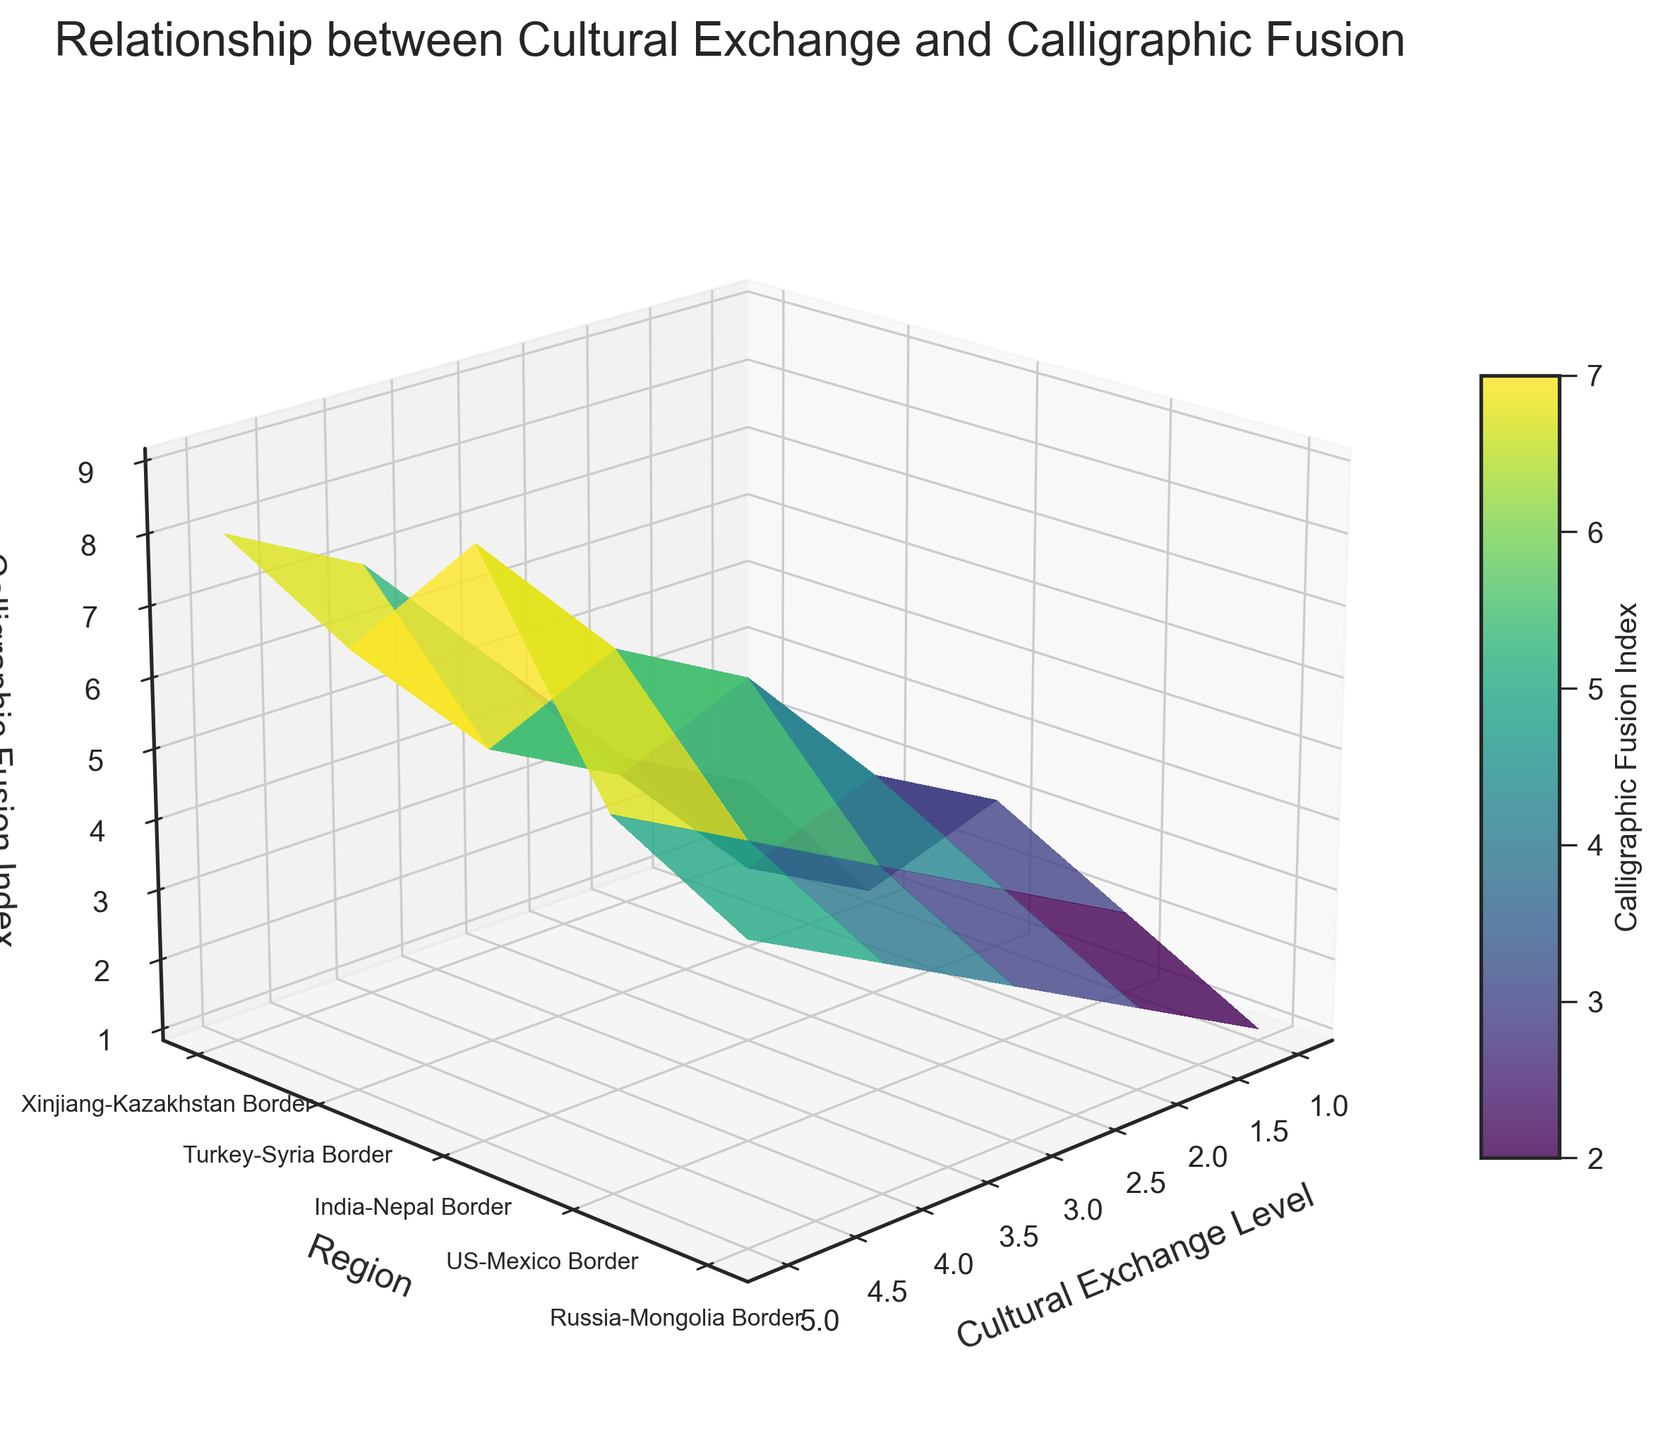What is the title of the plot? The title of the plot is usually located at the top of the figure. In this case, it reads "Relationship between Cultural Exchange and Calligraphic Fusion".
Answer: Relationship between Cultural Exchange and Calligraphic Fusion What do the colors represent in the plot? In a 3D surface plot, the colors usually indicate varying values on the z-axis. Here, the color represents the Calligraphic Fusion Index, as also denoted by the color bar.
Answer: Calligraphic Fusion Index Which region shows the highest Calligraphic Fusion Index? By examining the height of the peaks in the Z dimension, the India-Nepal Border shows the highest peak corresponding to the highest Calligraphic Fusion Index.
Answer: India-Nepal Border How does the Calligraphic Fusion Index change in the Xinjiang-Kazakhstan Border region as the Cultural Exchange Level increases? Observing the plot, the Calligraphic Fusion Index in the Xinjiang-Kazakhstan Border region appears to increase steadily as the Cultural Exchange Level goes from 1 to 5.
Answer: Increases steadily Does any region have a constant Calligraphic Fusion Index regardless of the Cultural Exchange Level? By checking for any flat lines parallel to the X-axis, the Russia-Mongolia Border region has a constant Calligraphic Fusion Index across all levels of cultural exchange.
Answer: Russia-Mongolia Border What is the difference in Calligraphic Fusion Index between the US-Mexico Border and Russia-Mongolia Border at a Cultural Exchange Level of 3? At a Cultural Exchange Level of 3, the Calligraphic Fusion Index for the US-Mexico Border is 4, and for Russia-Mongolia Border it is 3. Subtracting these values gives 4 - 3.
Answer: 1 Which region shows the most variation in the Calligraphic Fusion Index as Cultural Exchange Level changes? The India-Nepal Border exhibits the highest range from 3 to 9 in Calligraphic Fusion Index, indicating the most variation as Cultural Exchange Level increases.
Answer: India-Nepal Border Compare the Calligraphic Fusion Index at a Cultural Exchange Level of 2 for the Turkey-Syria Border and US-Mexico Border. Which region has a higher index? At a Cultural Exchange Level of 2, the Calligraphic Fusion Index for Turkey-Syria Border is 2 and for US-Mexico Border it is 3. Thus, the US-Mexico Border has a higher index.
Answer: US-Mexico Border What is the average Calligraphic Fusion Index for the India-Nepal Border region? The values for the India-Nepal Border are 3, 4, 6, 7, 9. Adding them gives 29. Dividing by 5 (the number of data points) yields 29/5.
Answer: 5.8 How does the Calligraphic Fusion Index in the Turkey-Syria Border region compare with that in the Xinjiang-Kazakhstan Border at the highest level of cultural exchange? At the highest Cultural Exchange Level of 5, the Calligraphic Fusion Index is 7 for the Turkey-Syria Border and 8 for the Xinjiang-Kazakhstan Border, meaning the latter is higher.
Answer: Xinjiang-Kazakhstan Border 